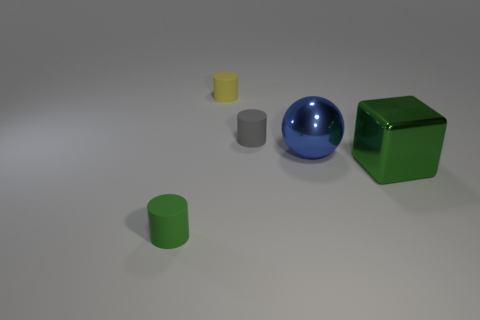Add 1 blue metal objects. How many objects exist? 6 Subtract all blocks. How many objects are left? 4 Add 5 large blue objects. How many large blue objects exist? 6 Subtract 1 yellow cylinders. How many objects are left? 4 Subtract all tiny green things. Subtract all blue objects. How many objects are left? 3 Add 4 gray cylinders. How many gray cylinders are left? 5 